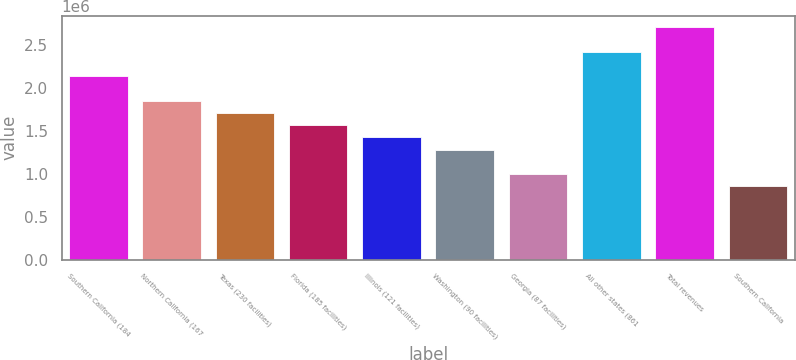Convert chart. <chart><loc_0><loc_0><loc_500><loc_500><bar_chart><fcel>Southern California (184<fcel>Northern California (167<fcel>Texas (230 facilities)<fcel>Florida (185 facilities)<fcel>Illinois (121 facilities)<fcel>Washington (90 facilities)<fcel>Georgia (87 facilities)<fcel>All other states (861<fcel>Total revenues<fcel>Southern California<nl><fcel>2.13496e+06<fcel>1.85031e+06<fcel>1.70799e+06<fcel>1.56566e+06<fcel>1.42334e+06<fcel>1.28101e+06<fcel>996363<fcel>2.41961e+06<fcel>2.70426e+06<fcel>854038<nl></chart> 